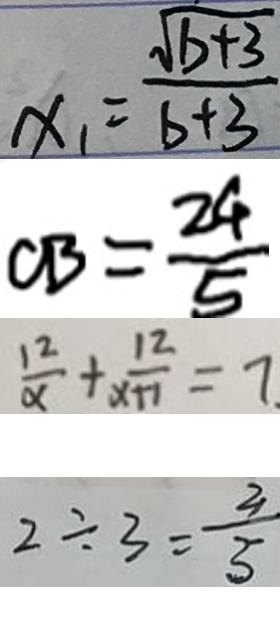<formula> <loc_0><loc_0><loc_500><loc_500>x _ { 1 } = \frac { \sqrt { b + 3 } } { b + 3 } 
 C B = \frac { 2 4 } { 5 } 
 \frac { 1 2 } { \alpha } + \frac { 1 2 } { x + 1 } = 7 
 2 \div 3 = \frac { 2 } { 3 }</formula> 